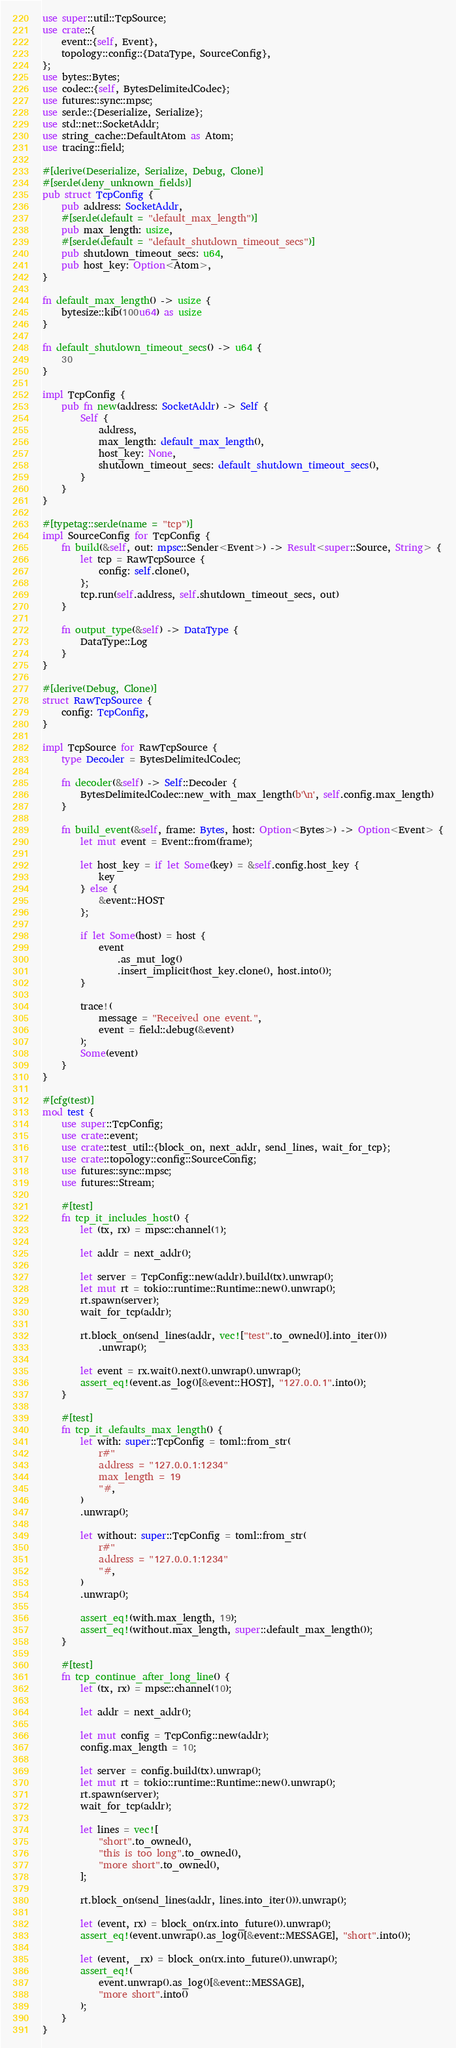<code> <loc_0><loc_0><loc_500><loc_500><_Rust_>use super::util::TcpSource;
use crate::{
    event::{self, Event},
    topology::config::{DataType, SourceConfig},
};
use bytes::Bytes;
use codec::{self, BytesDelimitedCodec};
use futures::sync::mpsc;
use serde::{Deserialize, Serialize};
use std::net::SocketAddr;
use string_cache::DefaultAtom as Atom;
use tracing::field;

#[derive(Deserialize, Serialize, Debug, Clone)]
#[serde(deny_unknown_fields)]
pub struct TcpConfig {
    pub address: SocketAddr,
    #[serde(default = "default_max_length")]
    pub max_length: usize,
    #[serde(default = "default_shutdown_timeout_secs")]
    pub shutdown_timeout_secs: u64,
    pub host_key: Option<Atom>,
}

fn default_max_length() -> usize {
    bytesize::kib(100u64) as usize
}

fn default_shutdown_timeout_secs() -> u64 {
    30
}

impl TcpConfig {
    pub fn new(address: SocketAddr) -> Self {
        Self {
            address,
            max_length: default_max_length(),
            host_key: None,
            shutdown_timeout_secs: default_shutdown_timeout_secs(),
        }
    }
}

#[typetag::serde(name = "tcp")]
impl SourceConfig for TcpConfig {
    fn build(&self, out: mpsc::Sender<Event>) -> Result<super::Source, String> {
        let tcp = RawTcpSource {
            config: self.clone(),
        };
        tcp.run(self.address, self.shutdown_timeout_secs, out)
    }

    fn output_type(&self) -> DataType {
        DataType::Log
    }
}

#[derive(Debug, Clone)]
struct RawTcpSource {
    config: TcpConfig,
}

impl TcpSource for RawTcpSource {
    type Decoder = BytesDelimitedCodec;

    fn decoder(&self) -> Self::Decoder {
        BytesDelimitedCodec::new_with_max_length(b'\n', self.config.max_length)
    }

    fn build_event(&self, frame: Bytes, host: Option<Bytes>) -> Option<Event> {
        let mut event = Event::from(frame);

        let host_key = if let Some(key) = &self.config.host_key {
            key
        } else {
            &event::HOST
        };

        if let Some(host) = host {
            event
                .as_mut_log()
                .insert_implicit(host_key.clone(), host.into());
        }

        trace!(
            message = "Received one event.",
            event = field::debug(&event)
        );
        Some(event)
    }
}

#[cfg(test)]
mod test {
    use super::TcpConfig;
    use crate::event;
    use crate::test_util::{block_on, next_addr, send_lines, wait_for_tcp};
    use crate::topology::config::SourceConfig;
    use futures::sync::mpsc;
    use futures::Stream;

    #[test]
    fn tcp_it_includes_host() {
        let (tx, rx) = mpsc::channel(1);

        let addr = next_addr();

        let server = TcpConfig::new(addr).build(tx).unwrap();
        let mut rt = tokio::runtime::Runtime::new().unwrap();
        rt.spawn(server);
        wait_for_tcp(addr);

        rt.block_on(send_lines(addr, vec!["test".to_owned()].into_iter()))
            .unwrap();

        let event = rx.wait().next().unwrap().unwrap();
        assert_eq!(event.as_log()[&event::HOST], "127.0.0.1".into());
    }

    #[test]
    fn tcp_it_defaults_max_length() {
        let with: super::TcpConfig = toml::from_str(
            r#"
            address = "127.0.0.1:1234"
            max_length = 19
            "#,
        )
        .unwrap();

        let without: super::TcpConfig = toml::from_str(
            r#"
            address = "127.0.0.1:1234"
            "#,
        )
        .unwrap();

        assert_eq!(with.max_length, 19);
        assert_eq!(without.max_length, super::default_max_length());
    }

    #[test]
    fn tcp_continue_after_long_line() {
        let (tx, rx) = mpsc::channel(10);

        let addr = next_addr();

        let mut config = TcpConfig::new(addr);
        config.max_length = 10;

        let server = config.build(tx).unwrap();
        let mut rt = tokio::runtime::Runtime::new().unwrap();
        rt.spawn(server);
        wait_for_tcp(addr);

        let lines = vec![
            "short".to_owned(),
            "this is too long".to_owned(),
            "more short".to_owned(),
        ];

        rt.block_on(send_lines(addr, lines.into_iter())).unwrap();

        let (event, rx) = block_on(rx.into_future()).unwrap();
        assert_eq!(event.unwrap().as_log()[&event::MESSAGE], "short".into());

        let (event, _rx) = block_on(rx.into_future()).unwrap();
        assert_eq!(
            event.unwrap().as_log()[&event::MESSAGE],
            "more short".into()
        );
    }
}
</code> 